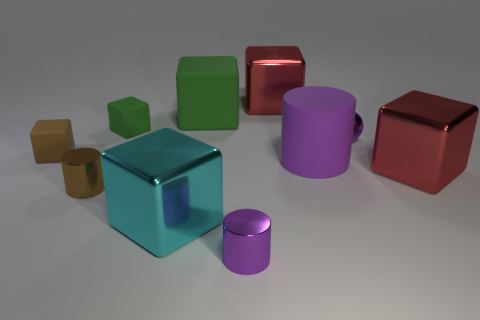Subtract all large purple rubber cylinders. How many cylinders are left? 2 Subtract 1 balls. How many balls are left? 0 Subtract all gray balls. How many purple cylinders are left? 2 Subtract all blocks. How many objects are left? 4 Subtract all red cubes. How many cubes are left? 4 Add 8 small rubber objects. How many small rubber objects are left? 10 Add 4 shiny spheres. How many shiny spheres exist? 5 Subtract 0 brown balls. How many objects are left? 10 Subtract all green cylinders. Subtract all yellow balls. How many cylinders are left? 3 Subtract all green objects. Subtract all small brown metallic objects. How many objects are left? 7 